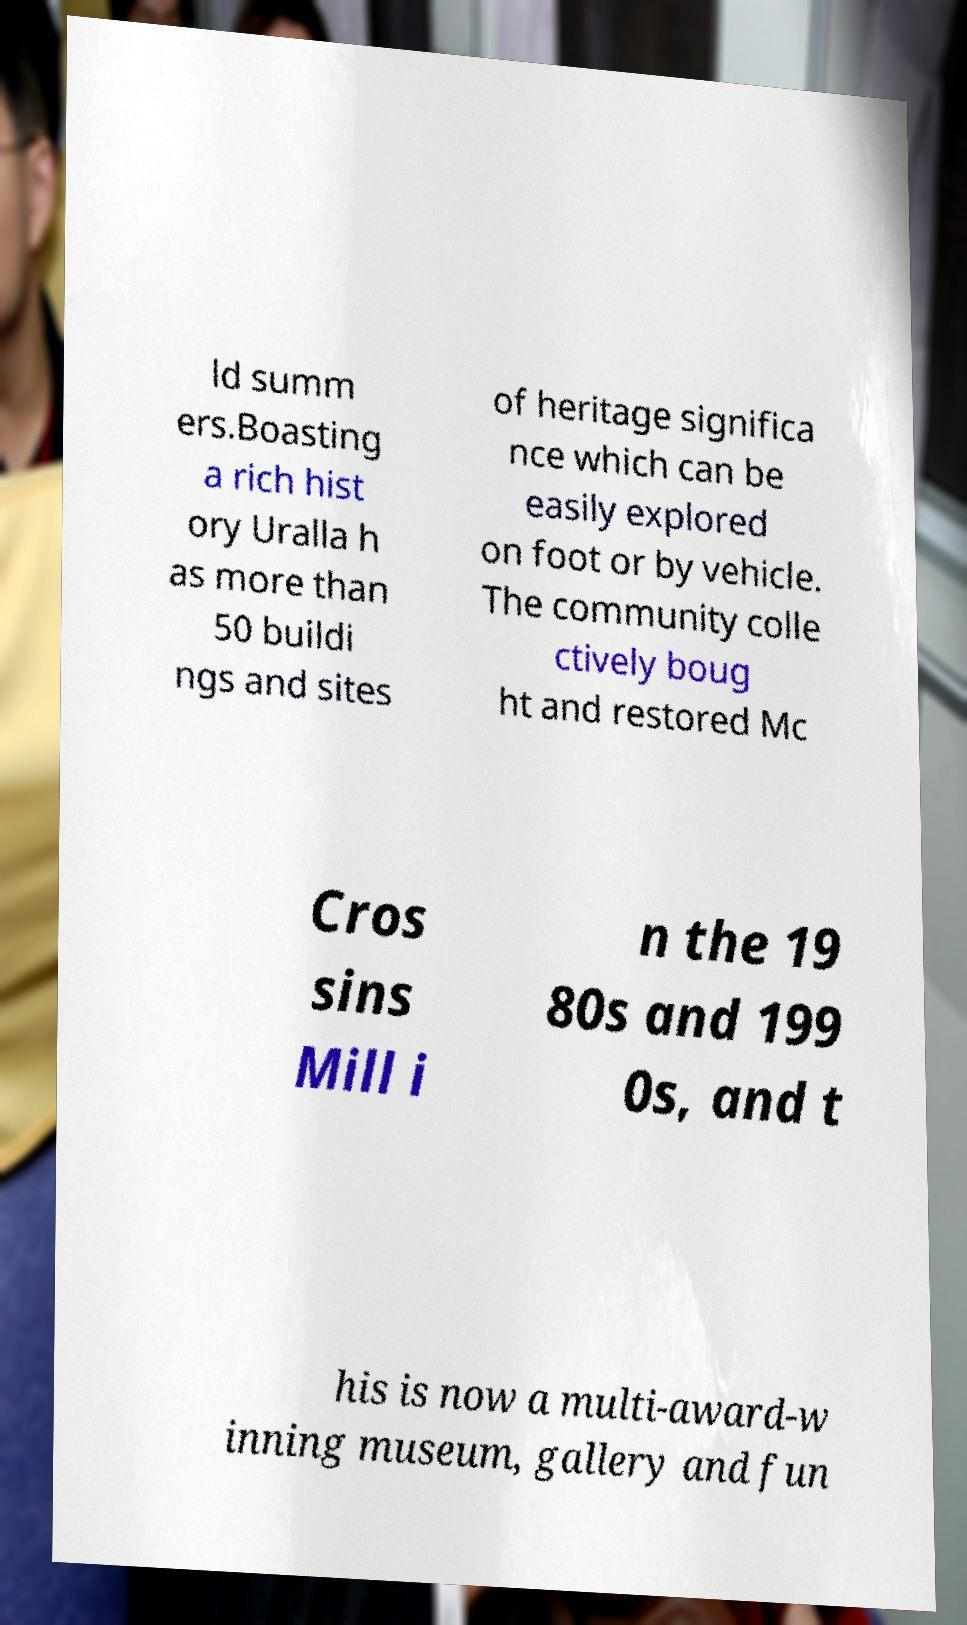Can you read and provide the text displayed in the image?This photo seems to have some interesting text. Can you extract and type it out for me? ld summ ers.Boasting a rich hist ory Uralla h as more than 50 buildi ngs and sites of heritage significa nce which can be easily explored on foot or by vehicle. The community colle ctively boug ht and restored Mc Cros sins Mill i n the 19 80s and 199 0s, and t his is now a multi-award-w inning museum, gallery and fun 